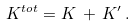Convert formula to latex. <formula><loc_0><loc_0><loc_500><loc_500>K ^ { t o t } = K \, + \, K ^ { \prime } \, .</formula> 